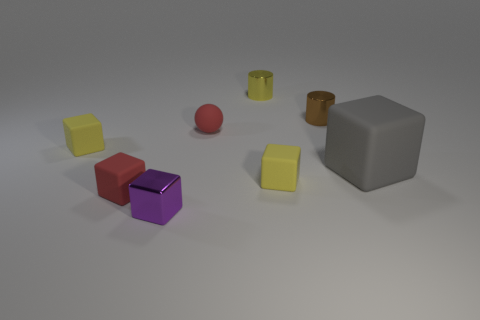Subtract all yellow cubes. How many were subtracted if there are1yellow cubes left? 1 Subtract all tiny shiny blocks. How many blocks are left? 4 Add 1 small green rubber blocks. How many objects exist? 9 Subtract 1 cylinders. How many cylinders are left? 1 Subtract all gray cubes. How many cubes are left? 4 Subtract all cubes. How many objects are left? 3 Subtract all cyan cylinders. How many yellow blocks are left? 2 Subtract all blue metallic balls. Subtract all large blocks. How many objects are left? 7 Add 6 yellow rubber objects. How many yellow rubber objects are left? 8 Add 2 small yellow rubber things. How many small yellow rubber things exist? 4 